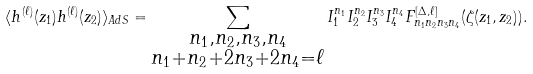Convert formula to latex. <formula><loc_0><loc_0><loc_500><loc_500>\langle h ^ { ( \ell ) } ( z _ { 1 } ) h ^ { ( \ell ) } ( z _ { 2 } ) \rangle _ { A d S } = \sum _ { \substack { n _ { 1 } , n _ { 2 } , n _ { 3 } , n _ { 4 } \\ n _ { 1 } + n _ { 2 } + 2 n _ { 3 } + 2 n _ { 4 } = \ell } } I _ { 1 } ^ { n _ { 1 } } I _ { 2 } ^ { n _ { 2 } } I _ { 3 } ^ { n _ { 3 } } I _ { 4 } ^ { n _ { 4 } } F ^ { [ \Delta , \ell ] } _ { n _ { 1 } n _ { 2 } n _ { 3 } n _ { 4 } } ( \zeta ( z _ { 1 } , z _ { 2 } ) ) .</formula> 